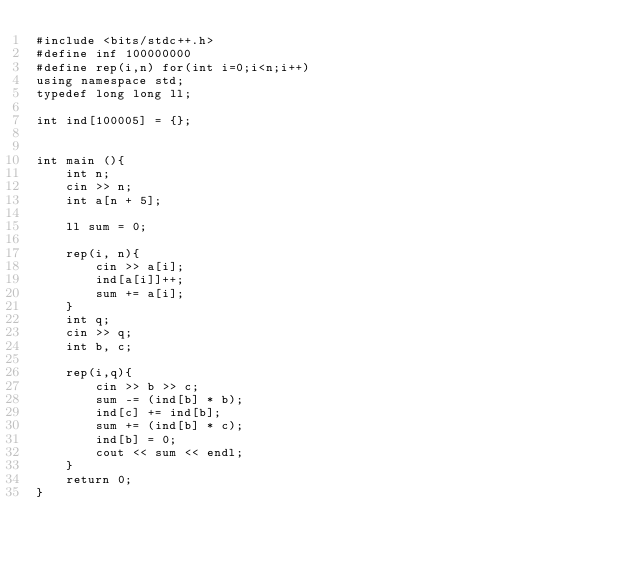Convert code to text. <code><loc_0><loc_0><loc_500><loc_500><_C++_>#include <bits/stdc++.h>
#define inf 100000000
#define rep(i,n) for(int i=0;i<n;i++) 
using namespace std;
typedef long long ll;

int ind[100005] = {};


int main (){
    int n;
    cin >> n;
    int a[n + 5];

    ll sum = 0;

    rep(i, n){
        cin >> a[i];
        ind[a[i]]++;
        sum += a[i];
    }
    int q;
    cin >> q;
    int b, c;

    rep(i,q){
        cin >> b >> c;
        sum -= (ind[b] * b);
        ind[c] += ind[b];
        sum += (ind[b] * c);
        ind[b] = 0;
        cout << sum << endl;
    }
    return 0;
}</code> 